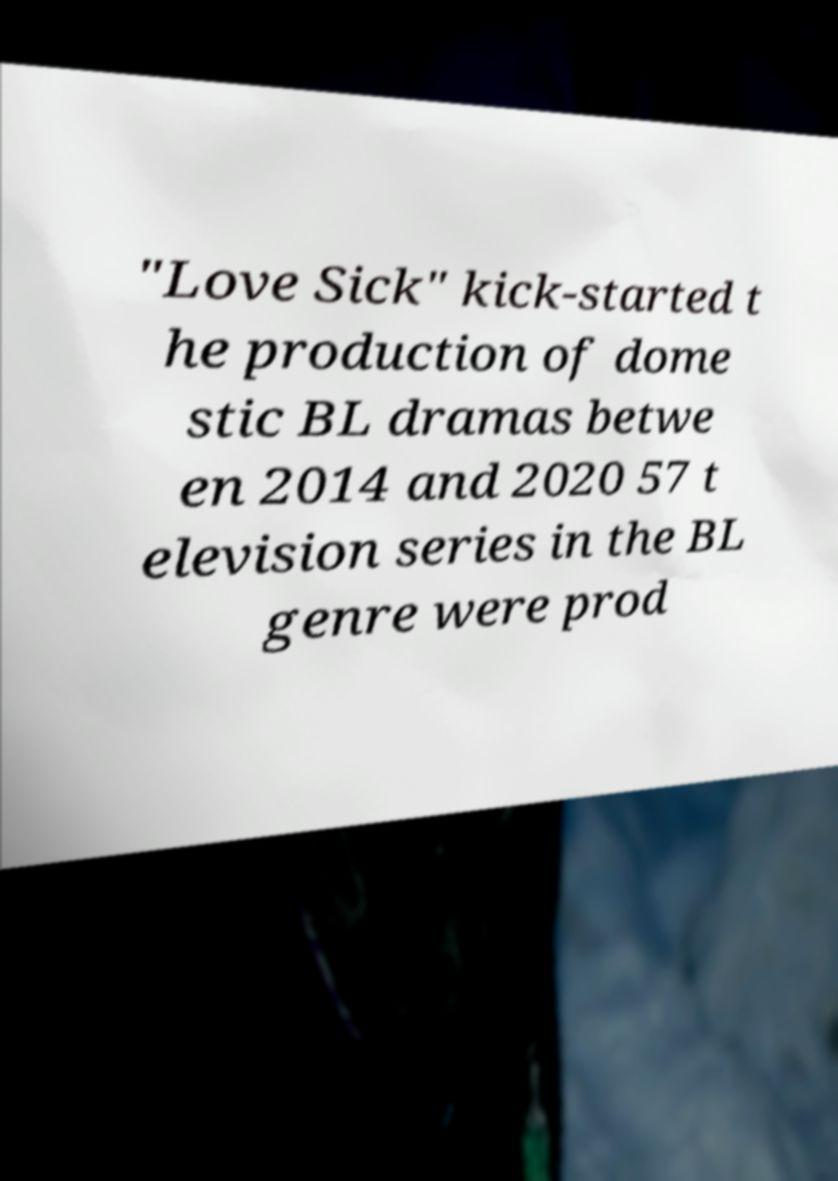Can you accurately transcribe the text from the provided image for me? "Love Sick" kick-started t he production of dome stic BL dramas betwe en 2014 and 2020 57 t elevision series in the BL genre were prod 